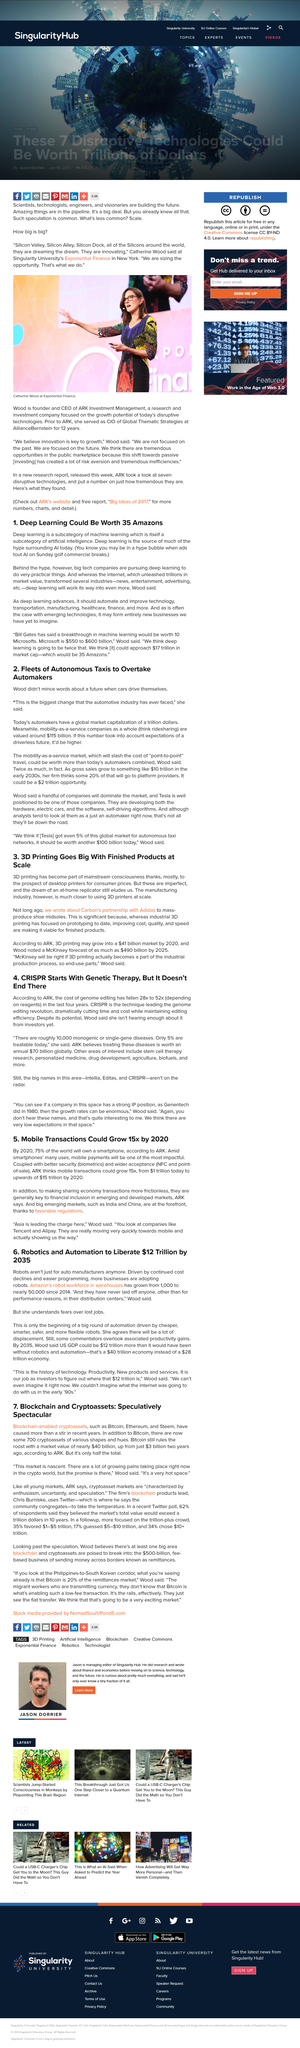Identify some key points in this picture. Since 2014, Amazon's robot workforce has grown significantly, from 1,000 to nearly 50,000, indicating a substantial increase in the use of automation in the company's operations. By 2035, robotics and automation are expected to liberate a total of $12 trillion globally. Adidas has partnered with Carbon to mass-produce shoe midsoles using carbon fiber technology. This innovative collaboration allows Adidas to create more sustainable and environmentally-friendly shoes for consumers. The use of carbon fiber in the production process results in midsoles that are both lightweight and strong, providing superior performance for Adidas customers. By working with Carbon, Adidas is able to reduce its environmental impact while continuing to provide high-quality products to its customers. By 2035, US GDP could be an estimated $12 trillion higher than it would have been without the proliferation of robotics and automation. By 2020, mobile transactions are projected to reach $15 trillion, increasing 15 times from their current value of $1 trillion, according to ARK Investment Management. 